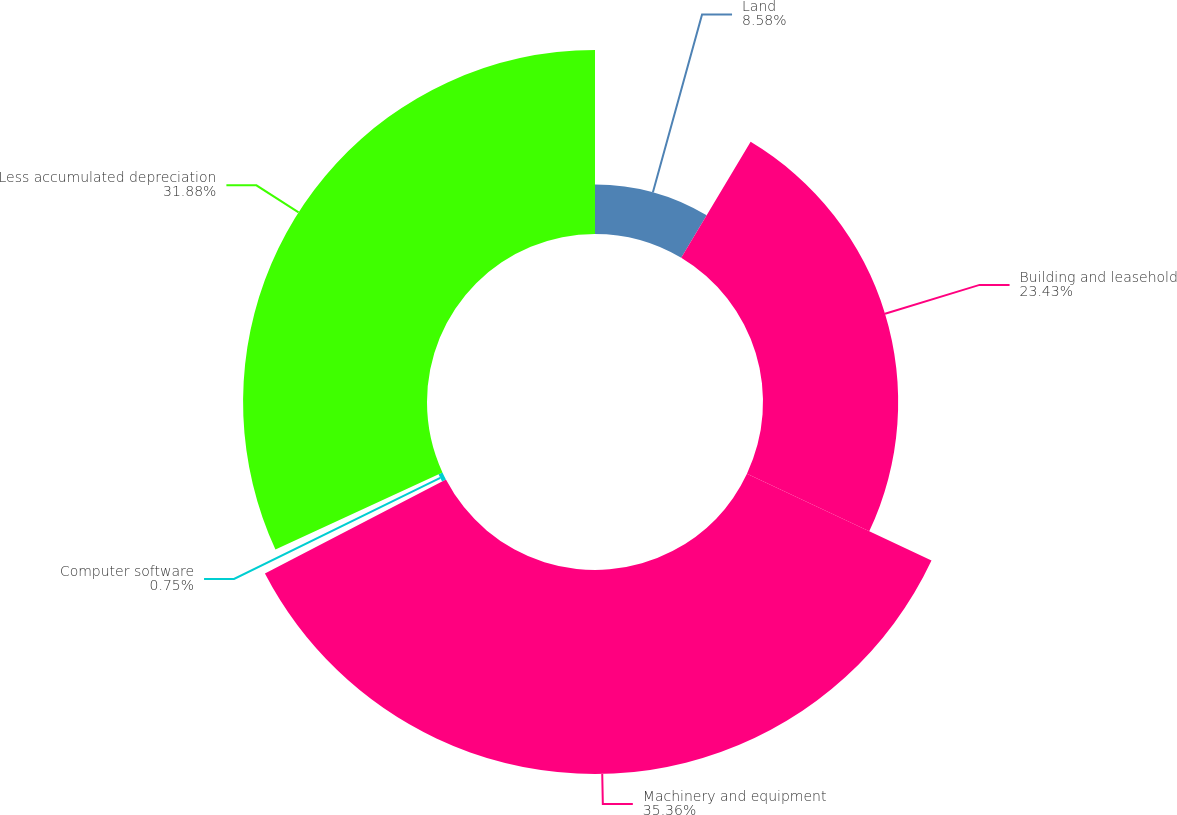<chart> <loc_0><loc_0><loc_500><loc_500><pie_chart><fcel>Land<fcel>Building and leasehold<fcel>Machinery and equipment<fcel>Computer software<fcel>Less accumulated depreciation<nl><fcel>8.58%<fcel>23.43%<fcel>35.36%<fcel>0.75%<fcel>31.88%<nl></chart> 